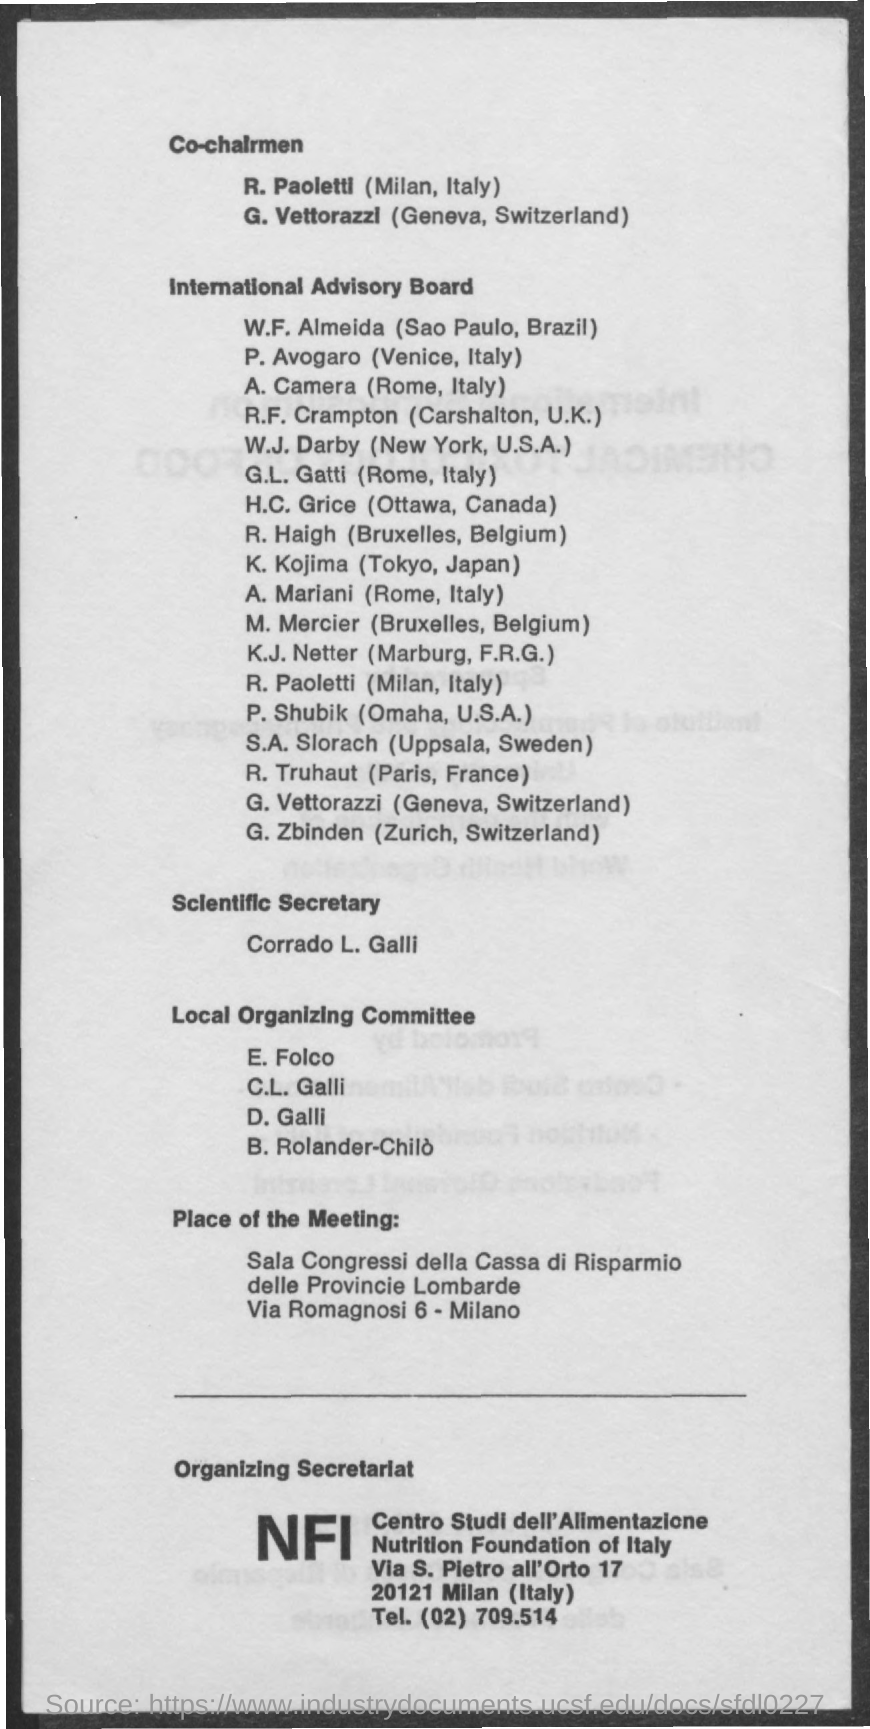What is the fullform of NFI?
Keep it short and to the point. Nutrition Foundation of Italy. Who is the Scientific Secretary as per the document?
Keep it short and to the point. Corrado L. Galli. Who is the International Advisory Board member from Tokyo, Japan?
Your answer should be compact. K. Kojima. What is the  Tel. No mentioned in the document?
Provide a succinct answer. (02) 709.514. 